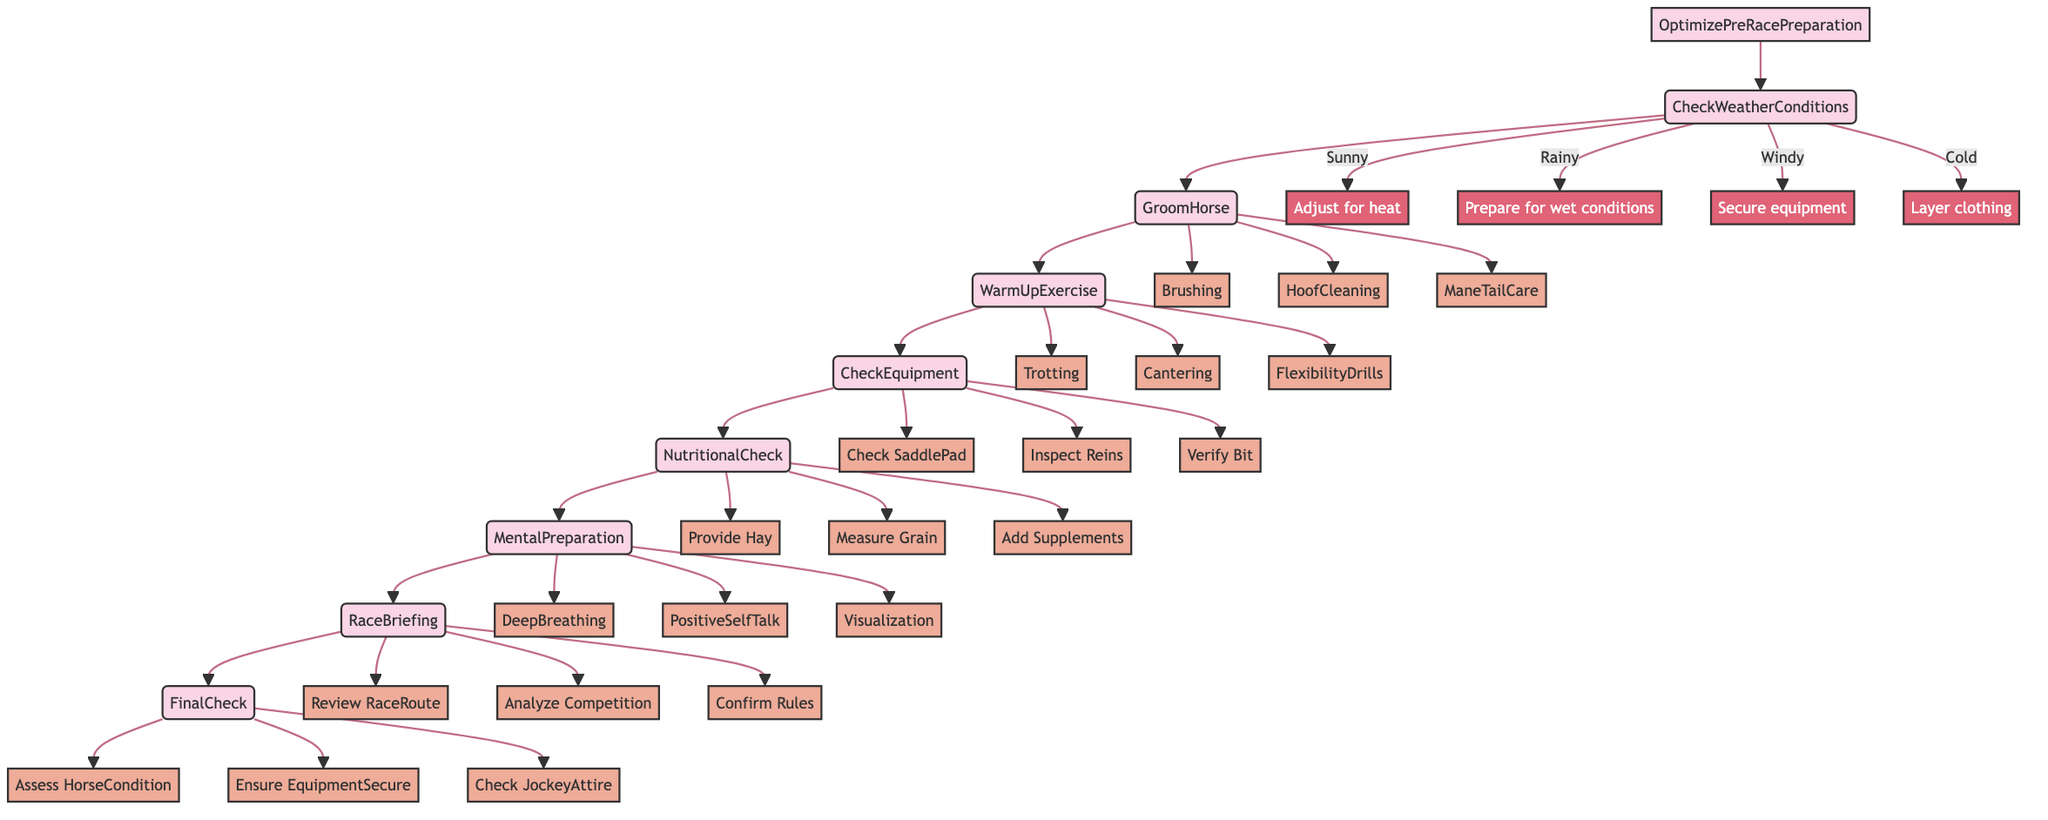What is the first step in the optimization process? The first step in the optimization process is to "CheckWeatherConditions." This is the initial action taken before proceeding to subsequent steps.
Answer: CheckWeatherConditions How many total steps are there in the preparation routine? By counting the main steps from the starting point to the final check, there are a total of eight steps in the preparation routine.
Answer: 8 Which condition involves preparing for wet conditions? The condition that involves preparing for wet conditions is "Rainy." This is one of the specific conditions listed under the "CheckWeatherConditions" step.
Answer: Rainy What is the last action to be taken before heading to the starting gate? The last action to be taken before heading to the starting gate is "FinalCheck." This step ensures everything is in order prior to the race.
Answer: FinalCheck How many exercises are listed under the "WarmUpExercise" step? There are three exercises listed under the "WarmUpExercise" step: Trotting, Cantering, and FlexibilityDrills.
Answer: 3 Which step requires the use of a checklist app? The step that requires the use of a checklist app is "FinalCheck." This tool helps ensure that all items are verified before the race begins.
Answer: ChecklistApp What are the three techniques involved in the mental preparation step? The three techniques involved in the "MentalPreparation" step are DeepBreathing, PositiveSelfTalk, and Visualization. These are strategies to mentally prepare for the race.
Answer: DeepBreathing, PositiveSelfTalk, Visualization In the "CheckEquipment" step, what is inspected alongside the saddle? Alongside the saddle, the reins and bit are inspected as part of ensuring all racing equipment is in perfect condition.
Answer: Reins, Bit What type of venue is used for the warm-up exercises? The venues used for warm-up exercises are "IndoorArena" and "TrainingTrack." These locations allow for effective warm-up activities for the horse.
Answer: IndoorArena, TrainingTrack 